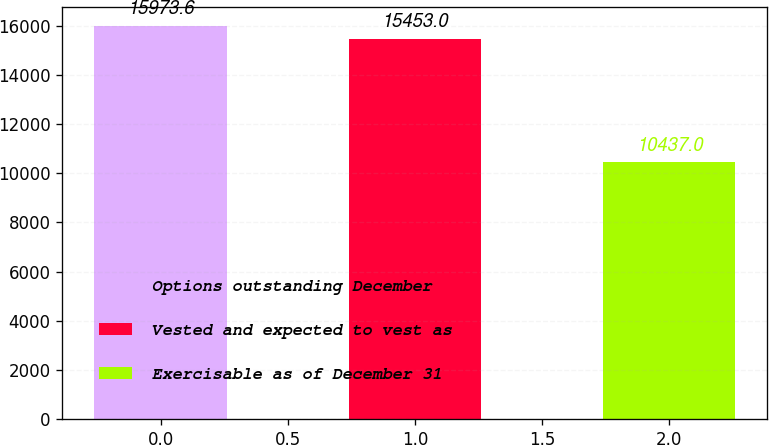<chart> <loc_0><loc_0><loc_500><loc_500><bar_chart><fcel>Options outstanding December<fcel>Vested and expected to vest as<fcel>Exercisable as of December 31<nl><fcel>15973.6<fcel>15453<fcel>10437<nl></chart> 